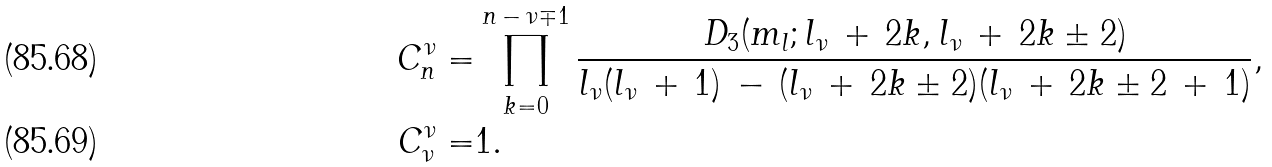<formula> <loc_0><loc_0><loc_500><loc_500>C _ { n } ^ { \nu } = & \prod _ { k = 0 } ^ { n \, - \, \nu \mp 1 } \frac { D _ { 3 } ( m _ { l } ; l _ { \nu } \, + \, 2 k , l _ { \nu } \, + \, 2 k \pm 2 ) } { l _ { \nu } ( l _ { \nu } \, + \, 1 ) \, - \, ( l _ { \nu } \, + \, 2 k \pm 2 ) ( l _ { \nu } \, + \, 2 k \pm 2 \, + \, 1 ) } , \\ C _ { \nu } ^ { \nu } = & 1 .</formula> 